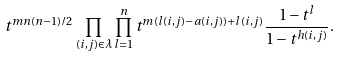Convert formula to latex. <formula><loc_0><loc_0><loc_500><loc_500>t ^ { m n ( n - 1 ) / 2 } \prod _ { ( i , j ) \in \lambda } \prod _ { l = 1 } ^ { n } t ^ { m ( l ( i , j ) - a ( i , j ) ) + l ( i , j ) } \frac { 1 - t ^ { l } } { 1 - t ^ { h ( i , j ) } } .</formula> 